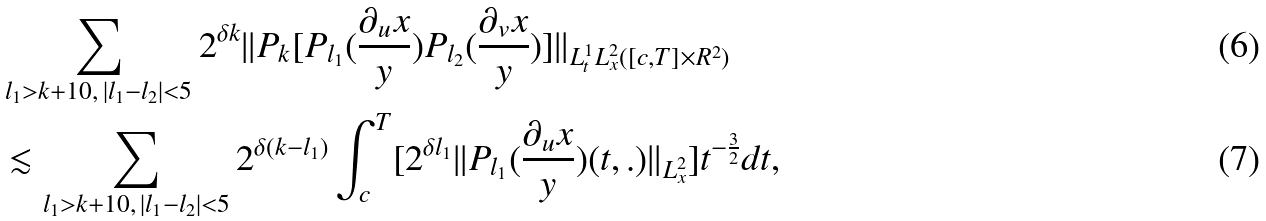Convert formula to latex. <formula><loc_0><loc_0><loc_500><loc_500>& \sum _ { l _ { 1 } > k + 1 0 , \, | l _ { 1 } - l _ { 2 } | < 5 } 2 ^ { \delta k } | | P _ { k } [ P _ { l _ { 1 } } ( \frac { \partial _ { u } { x } } { y } ) P _ { l _ { 2 } } ( \frac { \partial _ { v } { x } } { y } ) ] | | _ { L _ { t } ^ { 1 } L _ { x } ^ { 2 } ( [ c , T ] \times { R } ^ { 2 } ) } \\ & \lesssim \sum _ { l _ { 1 } > k + 1 0 , \, | l _ { 1 } - l _ { 2 } | < 5 } 2 ^ { \delta ( k - l _ { 1 } ) } \int _ { c } ^ { T } [ 2 ^ { \delta l _ { 1 } } | | P _ { l _ { 1 } } ( \frac { \partial _ { u } { x } } { y } ) ( t , . ) | | _ { L _ { x } ^ { 2 } } ] t ^ { - \frac { 3 } { 2 } } d t ,</formula> 